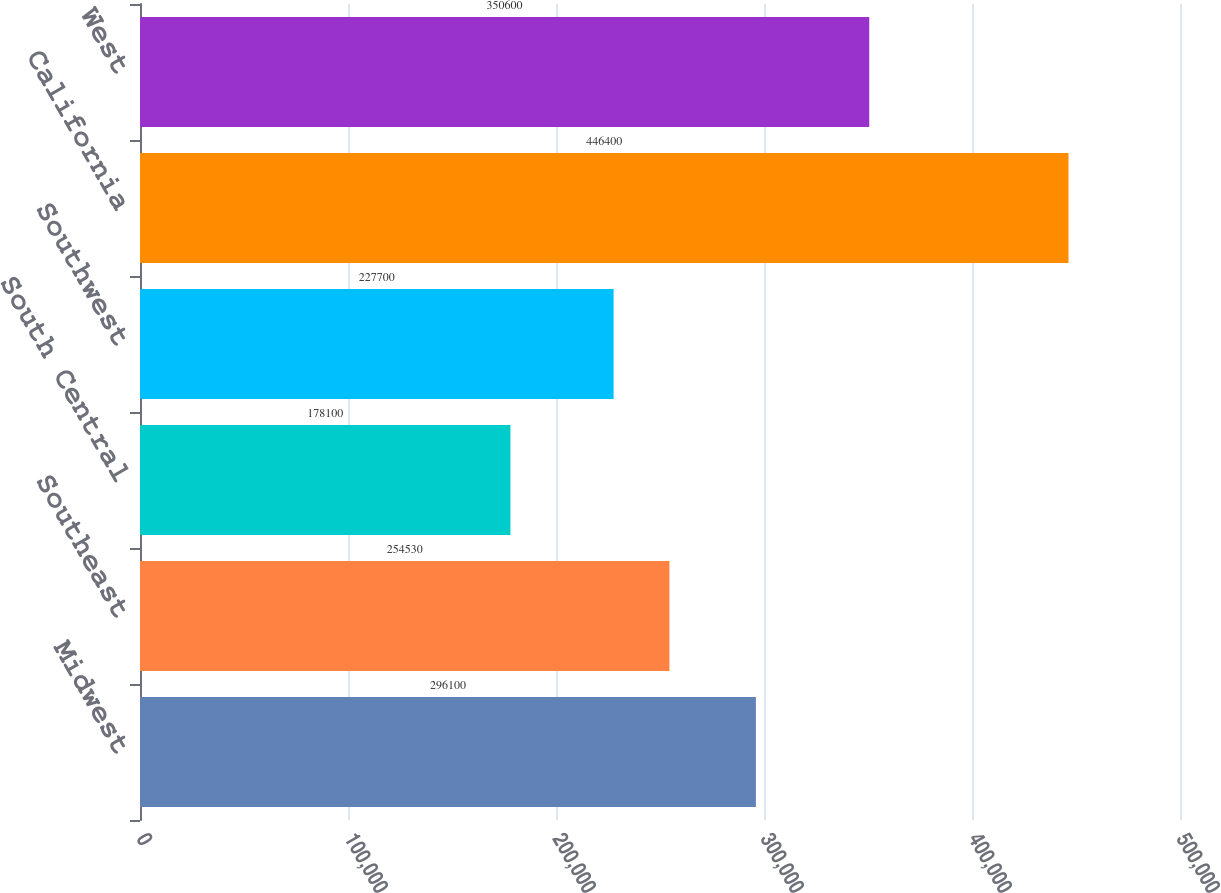Convert chart. <chart><loc_0><loc_0><loc_500><loc_500><bar_chart><fcel>Midwest<fcel>Southeast<fcel>South Central<fcel>Southwest<fcel>California<fcel>West<nl><fcel>296100<fcel>254530<fcel>178100<fcel>227700<fcel>446400<fcel>350600<nl></chart> 